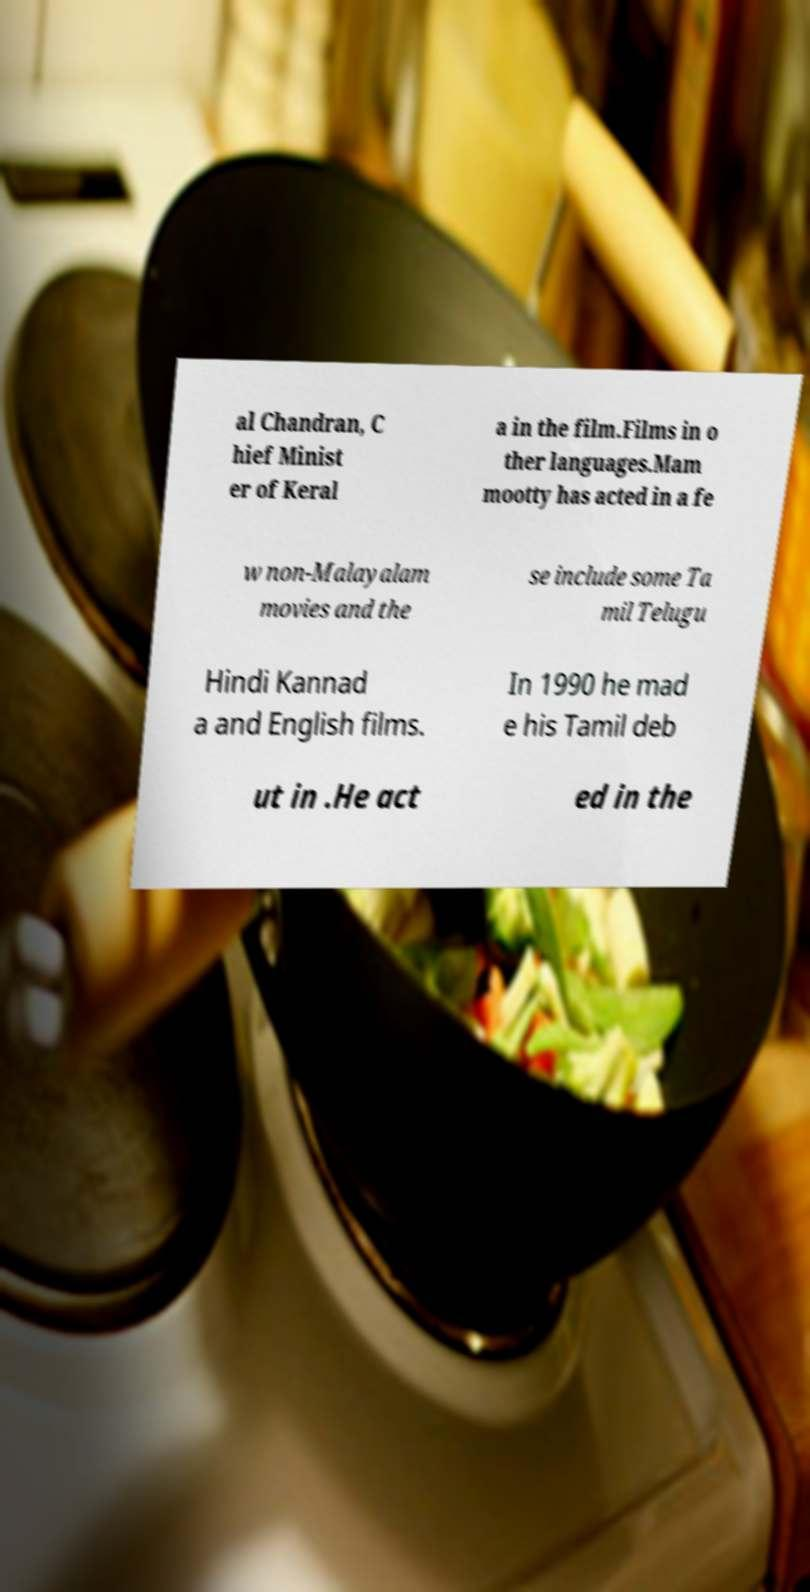Could you assist in decoding the text presented in this image and type it out clearly? al Chandran, C hief Minist er of Keral a in the film.Films in o ther languages.Mam mootty has acted in a fe w non-Malayalam movies and the se include some Ta mil Telugu Hindi Kannad a and English films. In 1990 he mad e his Tamil deb ut in .He act ed in the 